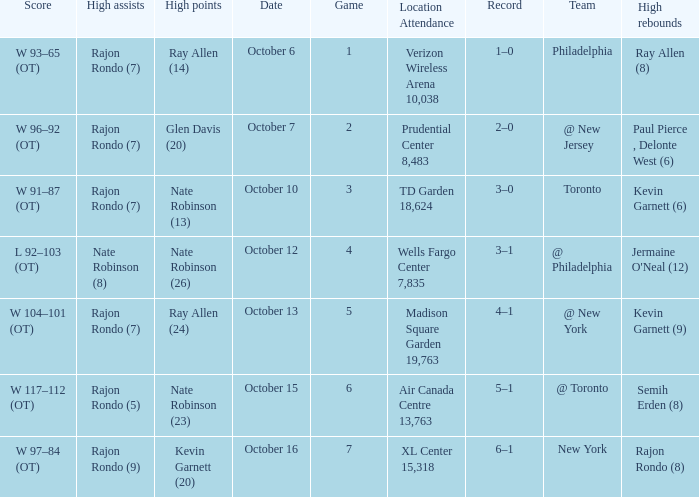Who had the most assists and how many did they have on October 7?  Rajon Rondo (7). 